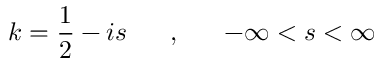<formula> <loc_0><loc_0><loc_500><loc_500>k = \frac { 1 } { 2 } - i s , - \infty < s < \infty</formula> 